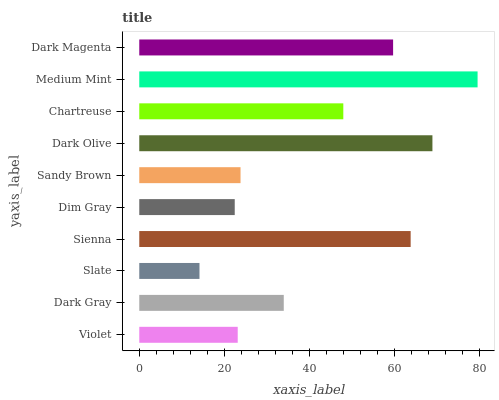Is Slate the minimum?
Answer yes or no. Yes. Is Medium Mint the maximum?
Answer yes or no. Yes. Is Dark Gray the minimum?
Answer yes or no. No. Is Dark Gray the maximum?
Answer yes or no. No. Is Dark Gray greater than Violet?
Answer yes or no. Yes. Is Violet less than Dark Gray?
Answer yes or no. Yes. Is Violet greater than Dark Gray?
Answer yes or no. No. Is Dark Gray less than Violet?
Answer yes or no. No. Is Chartreuse the high median?
Answer yes or no. Yes. Is Dark Gray the low median?
Answer yes or no. Yes. Is Slate the high median?
Answer yes or no. No. Is Chartreuse the low median?
Answer yes or no. No. 